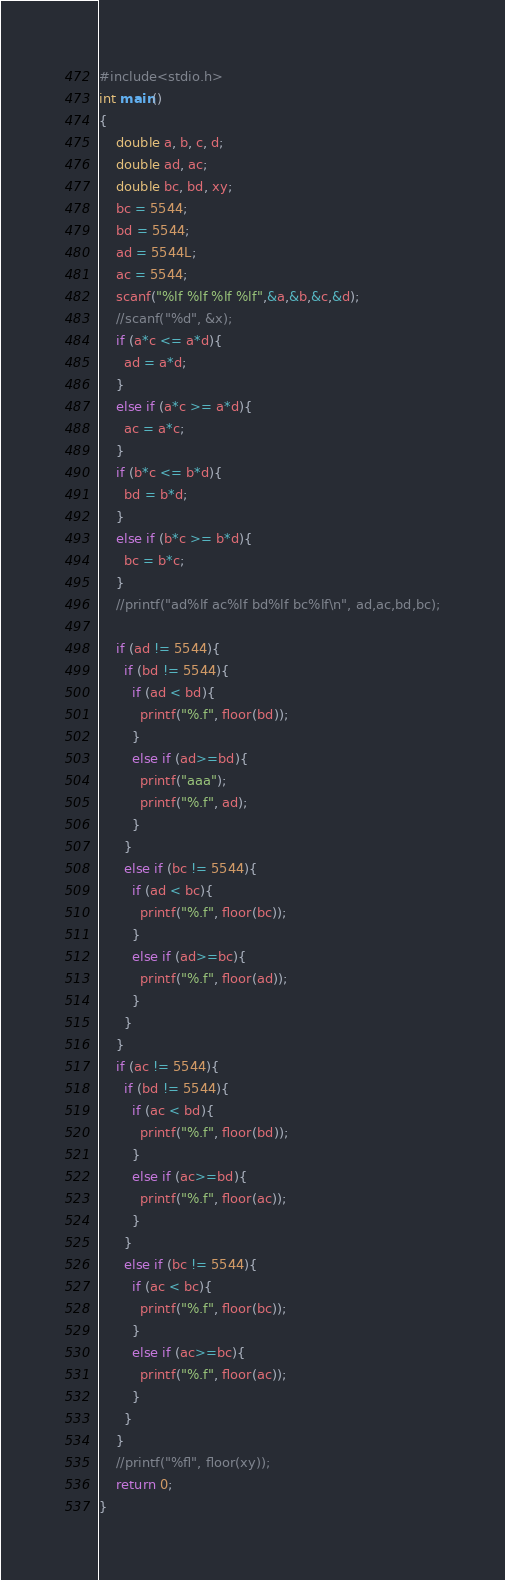<code> <loc_0><loc_0><loc_500><loc_500><_C_>#include<stdio.h>
int main()
{
    double a, b, c, d;
  	double ad, ac;
  	double bc, bd, xy;
  	bc = 5544;
  	bd = 5544;
  	ad = 5544L;
  	ac = 5544;
  	scanf("%lf %lf %lf %lf",&a,&b,&c,&d);
    //scanf("%d", &x);
    if (a*c <= a*d){
      ad = a*d;
    }
  	else if (a*c >= a*d){
      ac = a*c;
    }
  	if (b*c <= b*d){
      bd = b*d;
    }
  	else if (b*c >= b*d){
      bc = b*c;
    }
    //printf("ad%lf ac%lf bd%lf bc%lf\n", ad,ac,bd,bc);
  
  	if (ad != 5544){
      if (bd != 5544){
        if (ad < bd){
          printf("%.f", floor(bd));
        }
        else if (ad>=bd){
          printf("aaa");
          printf("%.f", ad);
        }
      }
      else if (bc != 5544){
        if (ad < bc){
          printf("%.f", floor(bc));
        }
        else if (ad>=bc){
          printf("%.f", floor(ad));
        }
      }
    }
  	if (ac != 5544){
      if (bd != 5544){
        if (ac < bd){
          printf("%.f", floor(bd));
        }
        else if (ac>=bd){
          printf("%.f", floor(ac));
        }
      }
      else if (bc != 5544){
        if (ac < bc){
          printf("%.f", floor(bc));
        }
        else if (ac>=bc){
          printf("%.f", floor(ac));
        }
      }
    }
  	//printf("%fl", floor(xy));
    return 0;
}</code> 